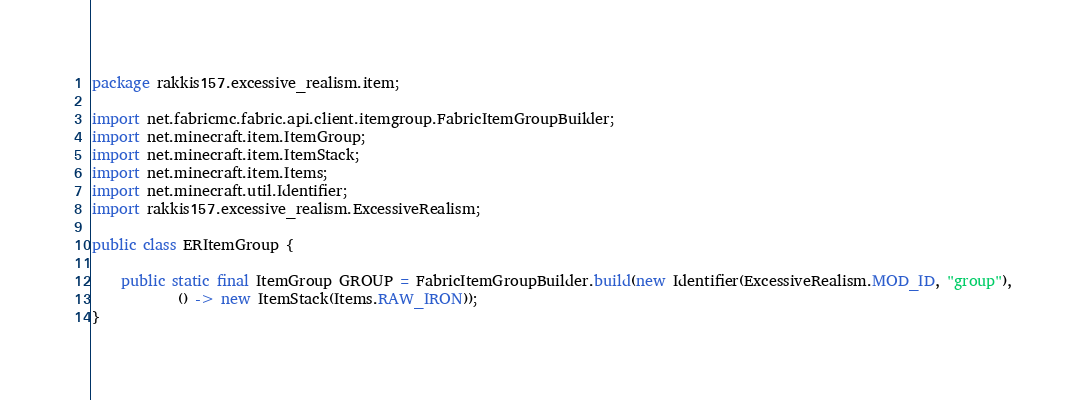<code> <loc_0><loc_0><loc_500><loc_500><_Java_>package rakkis157.excessive_realism.item;

import net.fabricmc.fabric.api.client.itemgroup.FabricItemGroupBuilder;
import net.minecraft.item.ItemGroup;
import net.minecraft.item.ItemStack;
import net.minecraft.item.Items;
import net.minecraft.util.Identifier;
import rakkis157.excessive_realism.ExcessiveRealism;

public class ERItemGroup {

    public static final ItemGroup GROUP = FabricItemGroupBuilder.build(new Identifier(ExcessiveRealism.MOD_ID, "group"),
            () -> new ItemStack(Items.RAW_IRON));
}
</code> 